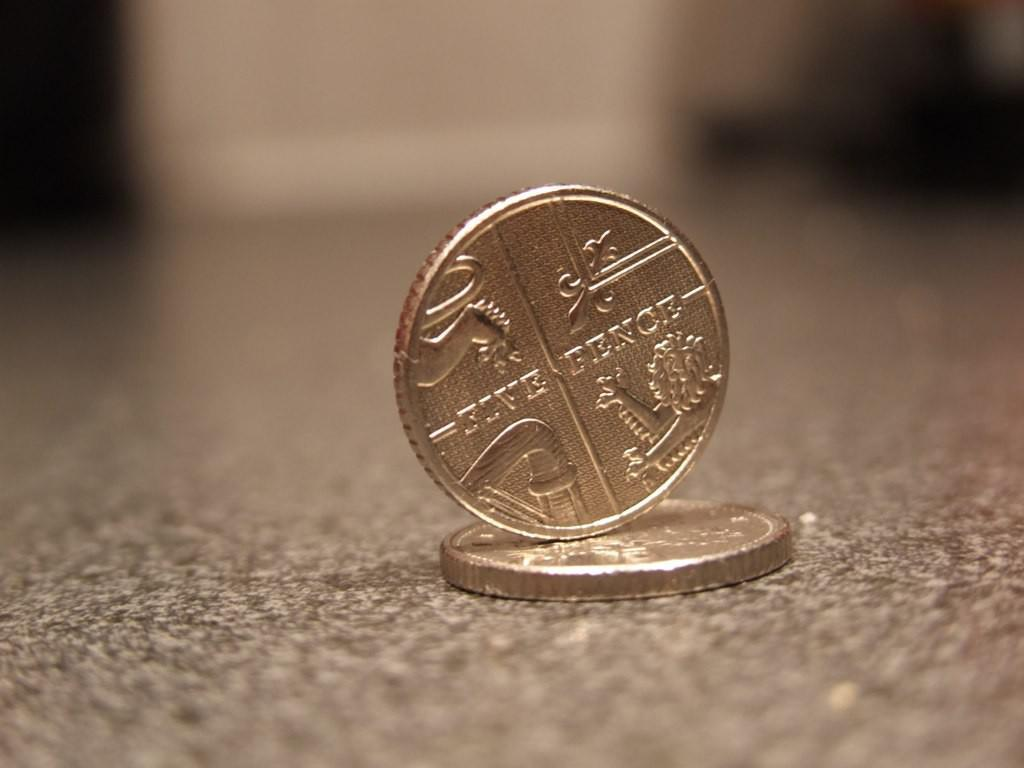<image>
Write a terse but informative summary of the picture. A five pence coin is balanced vertically on top of another coin that is resting flat against a surface. 